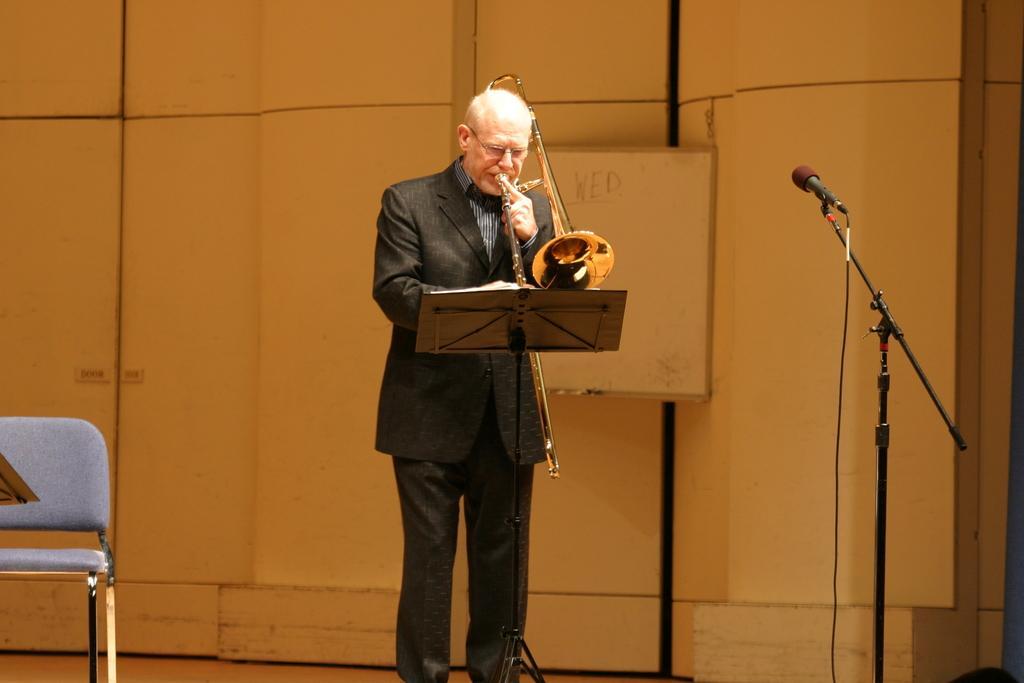Could you give a brief overview of what you see in this image? In this image, a old man is playing a musical instrument in-front of a stand. We can see book here. On right side, There is a microphone, stand, wire. Left side, There is a blue color chair. Background, there is a white board and wall we can see. 